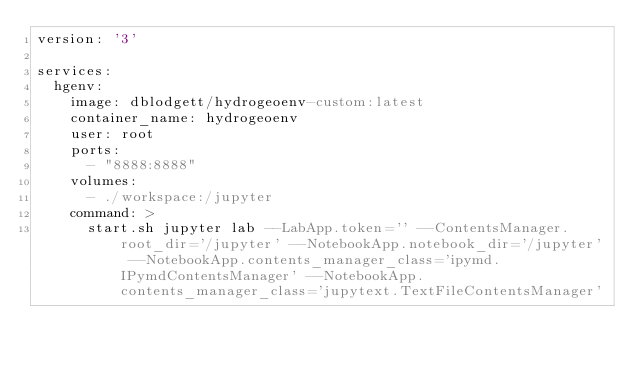Convert code to text. <code><loc_0><loc_0><loc_500><loc_500><_YAML_>version: '3'

services:
  hgenv:
    image: dblodgett/hydrogeoenv-custom:latest
    container_name: hydrogeoenv
    user: root
    ports:
      - "8888:8888"
    volumes:
      - ./workspace:/jupyter
    command: >
      start.sh jupyter lab --LabApp.token='' --ContentsManager.root_dir='/jupyter' --NotebookApp.notebook_dir='/jupyter' --NotebookApp.contents_manager_class='ipymd.IPymdContentsManager' --NotebookApp.contents_manager_class='jupytext.TextFileContentsManager'
             </code> 